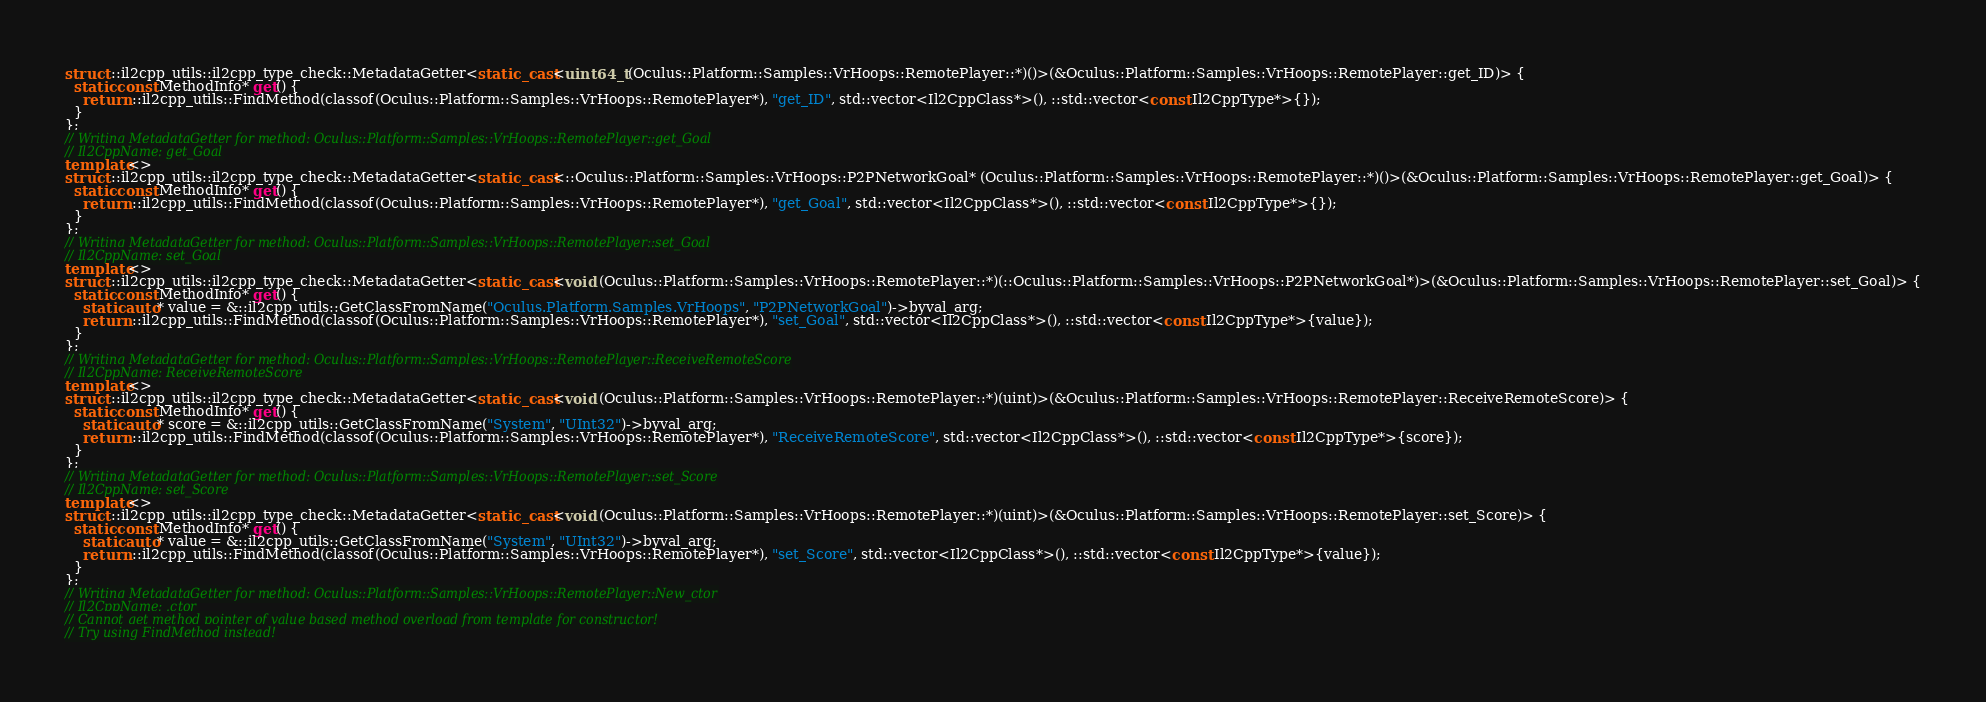<code> <loc_0><loc_0><loc_500><loc_500><_C++_>struct ::il2cpp_utils::il2cpp_type_check::MetadataGetter<static_cast<uint64_t (Oculus::Platform::Samples::VrHoops::RemotePlayer::*)()>(&Oculus::Platform::Samples::VrHoops::RemotePlayer::get_ID)> {
  static const MethodInfo* get() {
    return ::il2cpp_utils::FindMethod(classof(Oculus::Platform::Samples::VrHoops::RemotePlayer*), "get_ID", std::vector<Il2CppClass*>(), ::std::vector<const Il2CppType*>{});
  }
};
// Writing MetadataGetter for method: Oculus::Platform::Samples::VrHoops::RemotePlayer::get_Goal
// Il2CppName: get_Goal
template<>
struct ::il2cpp_utils::il2cpp_type_check::MetadataGetter<static_cast<::Oculus::Platform::Samples::VrHoops::P2PNetworkGoal* (Oculus::Platform::Samples::VrHoops::RemotePlayer::*)()>(&Oculus::Platform::Samples::VrHoops::RemotePlayer::get_Goal)> {
  static const MethodInfo* get() {
    return ::il2cpp_utils::FindMethod(classof(Oculus::Platform::Samples::VrHoops::RemotePlayer*), "get_Goal", std::vector<Il2CppClass*>(), ::std::vector<const Il2CppType*>{});
  }
};
// Writing MetadataGetter for method: Oculus::Platform::Samples::VrHoops::RemotePlayer::set_Goal
// Il2CppName: set_Goal
template<>
struct ::il2cpp_utils::il2cpp_type_check::MetadataGetter<static_cast<void (Oculus::Platform::Samples::VrHoops::RemotePlayer::*)(::Oculus::Platform::Samples::VrHoops::P2PNetworkGoal*)>(&Oculus::Platform::Samples::VrHoops::RemotePlayer::set_Goal)> {
  static const MethodInfo* get() {
    static auto* value = &::il2cpp_utils::GetClassFromName("Oculus.Platform.Samples.VrHoops", "P2PNetworkGoal")->byval_arg;
    return ::il2cpp_utils::FindMethod(classof(Oculus::Platform::Samples::VrHoops::RemotePlayer*), "set_Goal", std::vector<Il2CppClass*>(), ::std::vector<const Il2CppType*>{value});
  }
};
// Writing MetadataGetter for method: Oculus::Platform::Samples::VrHoops::RemotePlayer::ReceiveRemoteScore
// Il2CppName: ReceiveRemoteScore
template<>
struct ::il2cpp_utils::il2cpp_type_check::MetadataGetter<static_cast<void (Oculus::Platform::Samples::VrHoops::RemotePlayer::*)(uint)>(&Oculus::Platform::Samples::VrHoops::RemotePlayer::ReceiveRemoteScore)> {
  static const MethodInfo* get() {
    static auto* score = &::il2cpp_utils::GetClassFromName("System", "UInt32")->byval_arg;
    return ::il2cpp_utils::FindMethod(classof(Oculus::Platform::Samples::VrHoops::RemotePlayer*), "ReceiveRemoteScore", std::vector<Il2CppClass*>(), ::std::vector<const Il2CppType*>{score});
  }
};
// Writing MetadataGetter for method: Oculus::Platform::Samples::VrHoops::RemotePlayer::set_Score
// Il2CppName: set_Score
template<>
struct ::il2cpp_utils::il2cpp_type_check::MetadataGetter<static_cast<void (Oculus::Platform::Samples::VrHoops::RemotePlayer::*)(uint)>(&Oculus::Platform::Samples::VrHoops::RemotePlayer::set_Score)> {
  static const MethodInfo* get() {
    static auto* value = &::il2cpp_utils::GetClassFromName("System", "UInt32")->byval_arg;
    return ::il2cpp_utils::FindMethod(classof(Oculus::Platform::Samples::VrHoops::RemotePlayer*), "set_Score", std::vector<Il2CppClass*>(), ::std::vector<const Il2CppType*>{value});
  }
};
// Writing MetadataGetter for method: Oculus::Platform::Samples::VrHoops::RemotePlayer::New_ctor
// Il2CppName: .ctor
// Cannot get method pointer of value based method overload from template for constructor!
// Try using FindMethod instead!
</code> 